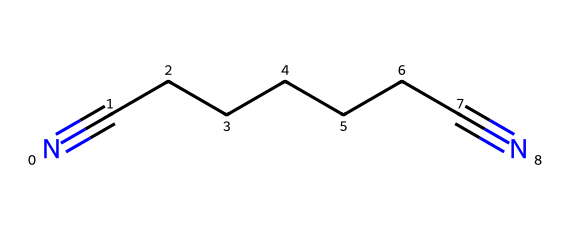What is the molecular formula of adiponitrile? The structure shows there are 8 carbon atoms from the chain (CCCCCC) and 2 nitrogen atoms produced by the nitrile groups (N#) on both ends. Thus, the molecular formula can be derived as C8H14N2, as each carbon typically bonds with two hydrogens in an alkane chain except the terminal ones which only bond with one.
Answer: C8H14N2 How many triple bonds are in adiponitrile? By examining the structural representation, we see that each nitrile group (N#) indicates a triple bond between carbon and nitrogen at both ends of the carbon chain. Therefore, there are two triple bonds present in the molecule.
Answer: 2 What type of functional groups are present in adiponitrile? Adiponitrile contains nitrile functional groups, which are characterized by the presence of carbon-nitrogen triple bonds. Both ends of the carbon chain exhibit this functional group, determining it as a nitrile compound.
Answer: nitrile How many carbon atoms are present in adiponitrile? Counting from the structural formula, the chain consists of 8 carbon atoms linearly arranged between the two terminal nitrile groups.
Answer: 8 What is the role of adiponitrile in the production of nylon? In nylon production, adiponitrile acts as a key precursor or monomer, which is polymerized to form nylon-6,6 through a process involving the reaction with hexamethylenediamine. This establishes its importance in producing this synthetic polymer.
Answer: precursor What kind of reaction is typically involved in the formation of nylon from adiponitrile? Adiponitrile undergoes a condensation reaction with hexamethylenediamine, forming nylon-6,6. This involves the release of water as a byproduct during the amine and nitrile functionalities' reaction.
Answer: condensation reaction 